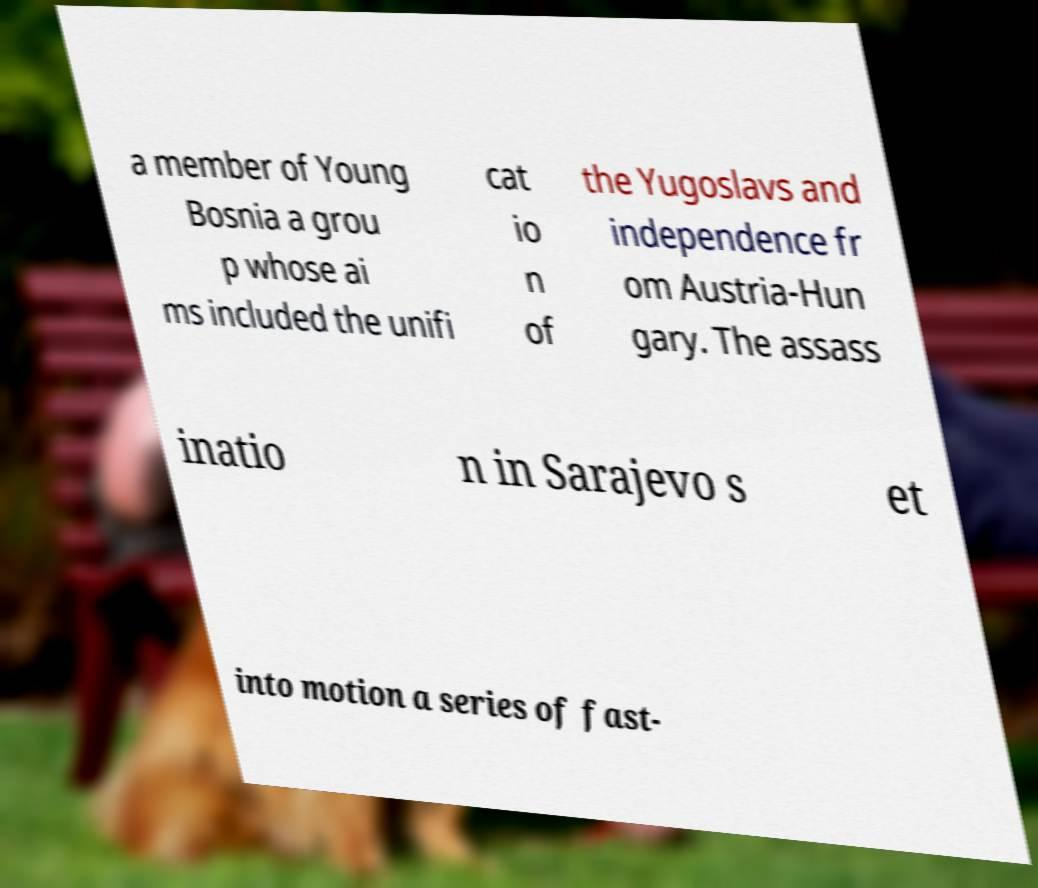I need the written content from this picture converted into text. Can you do that? a member of Young Bosnia a grou p whose ai ms included the unifi cat io n of the Yugoslavs and independence fr om Austria-Hun gary. The assass inatio n in Sarajevo s et into motion a series of fast- 